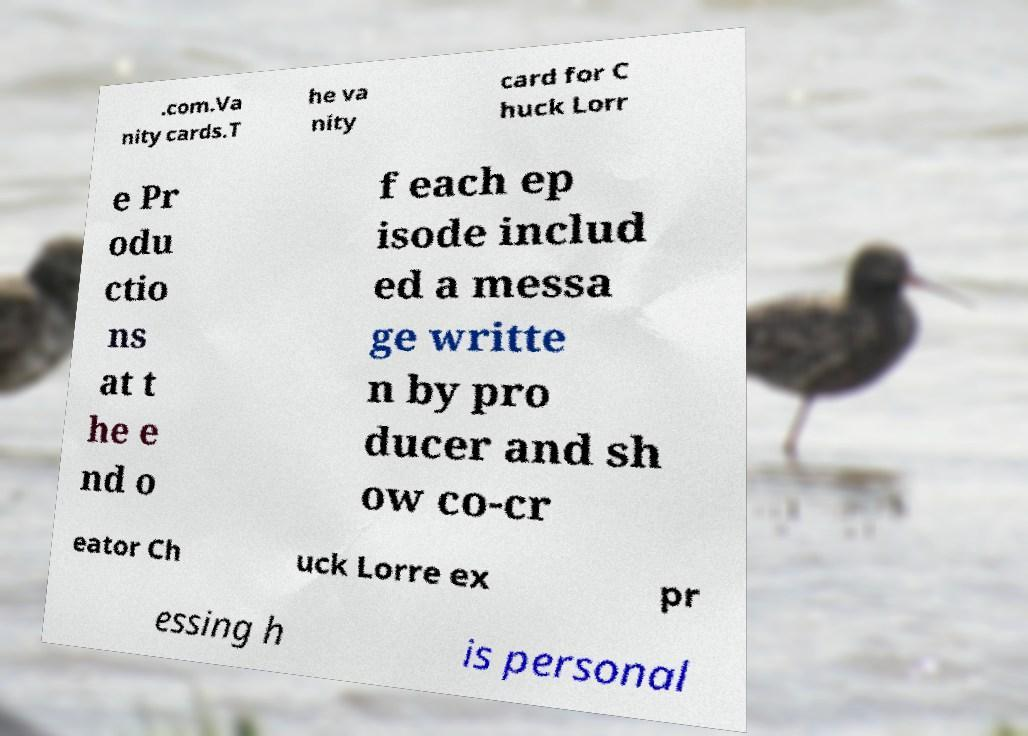Please identify and transcribe the text found in this image. .com.Va nity cards.T he va nity card for C huck Lorr e Pr odu ctio ns at t he e nd o f each ep isode includ ed a messa ge writte n by pro ducer and sh ow co-cr eator Ch uck Lorre ex pr essing h is personal 